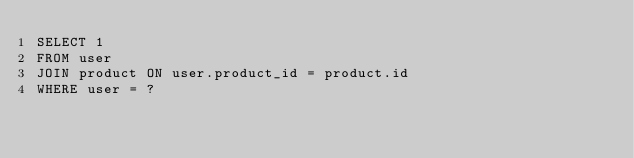Convert code to text. <code><loc_0><loc_0><loc_500><loc_500><_SQL_>SELECT 1
FROM user
JOIN product ON user.product_id = product.id
WHERE user = ?</code> 